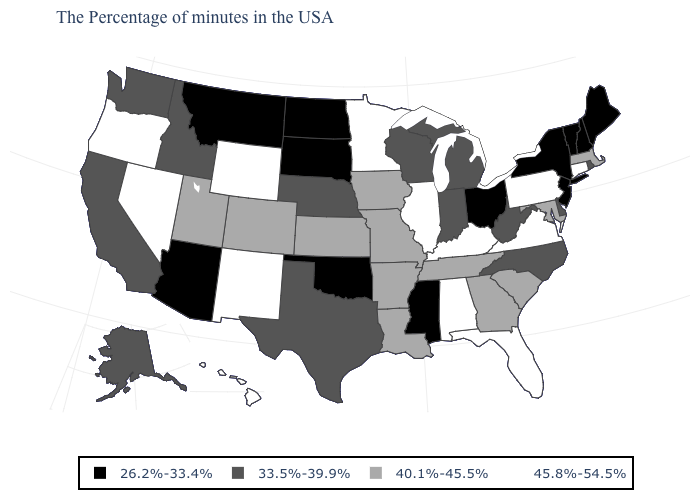Is the legend a continuous bar?
Short answer required. No. What is the value of New York?
Keep it brief. 26.2%-33.4%. What is the value of Montana?
Answer briefly. 26.2%-33.4%. What is the value of Colorado?
Answer briefly. 40.1%-45.5%. Does Arkansas have the lowest value in the USA?
Give a very brief answer. No. Name the states that have a value in the range 40.1%-45.5%?
Give a very brief answer. Massachusetts, Maryland, South Carolina, Georgia, Tennessee, Louisiana, Missouri, Arkansas, Iowa, Kansas, Colorado, Utah. Does Michigan have the highest value in the MidWest?
Write a very short answer. No. What is the highest value in the USA?
Keep it brief. 45.8%-54.5%. What is the value of Georgia?
Keep it brief. 40.1%-45.5%. What is the value of Utah?
Concise answer only. 40.1%-45.5%. What is the lowest value in states that border New York?
Write a very short answer. 26.2%-33.4%. What is the value of Colorado?
Keep it brief. 40.1%-45.5%. What is the highest value in the Northeast ?
Give a very brief answer. 45.8%-54.5%. Does Texas have the highest value in the USA?
Short answer required. No. Name the states that have a value in the range 26.2%-33.4%?
Keep it brief. Maine, New Hampshire, Vermont, New York, New Jersey, Ohio, Mississippi, Oklahoma, South Dakota, North Dakota, Montana, Arizona. 